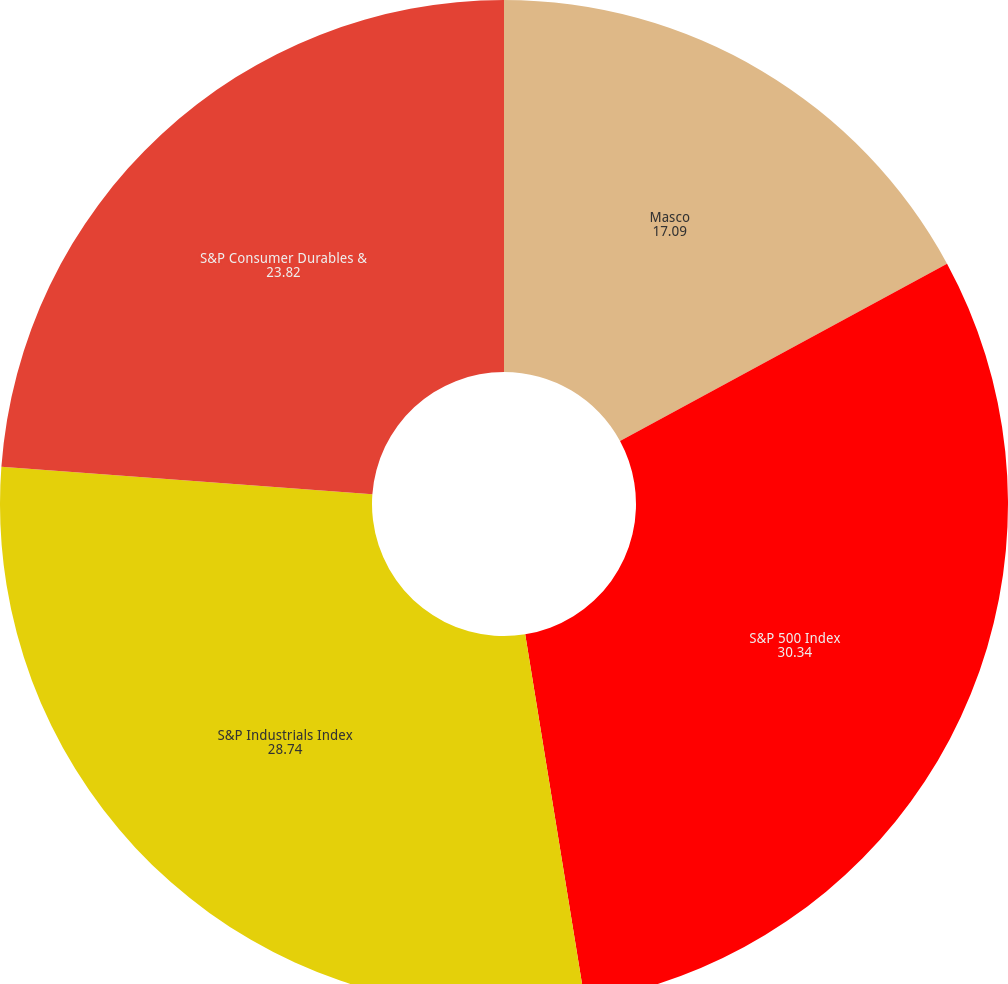Convert chart to OTSL. <chart><loc_0><loc_0><loc_500><loc_500><pie_chart><fcel>Masco<fcel>S&P 500 Index<fcel>S&P Industrials Index<fcel>S&P Consumer Durables &<nl><fcel>17.09%<fcel>30.34%<fcel>28.74%<fcel>23.82%<nl></chart> 